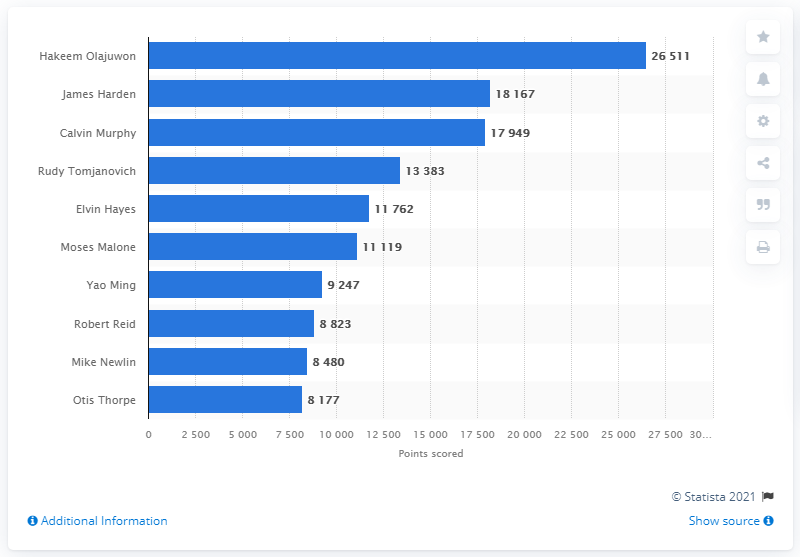Mention a couple of crucial points in this snapshot. The career points leader of the Houston Rockets is Hakeem Olajuwon. 